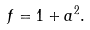<formula> <loc_0><loc_0><loc_500><loc_500>f = 1 + a ^ { 2 } .</formula> 